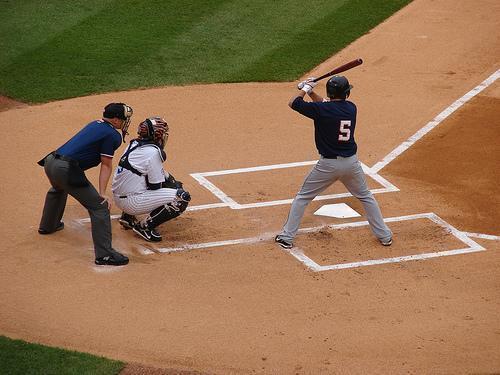How many umpires are visible?
Give a very brief answer. 1. How many people are there?
Give a very brief answer. 3. How many have blue shirts?
Give a very brief answer. 2. 